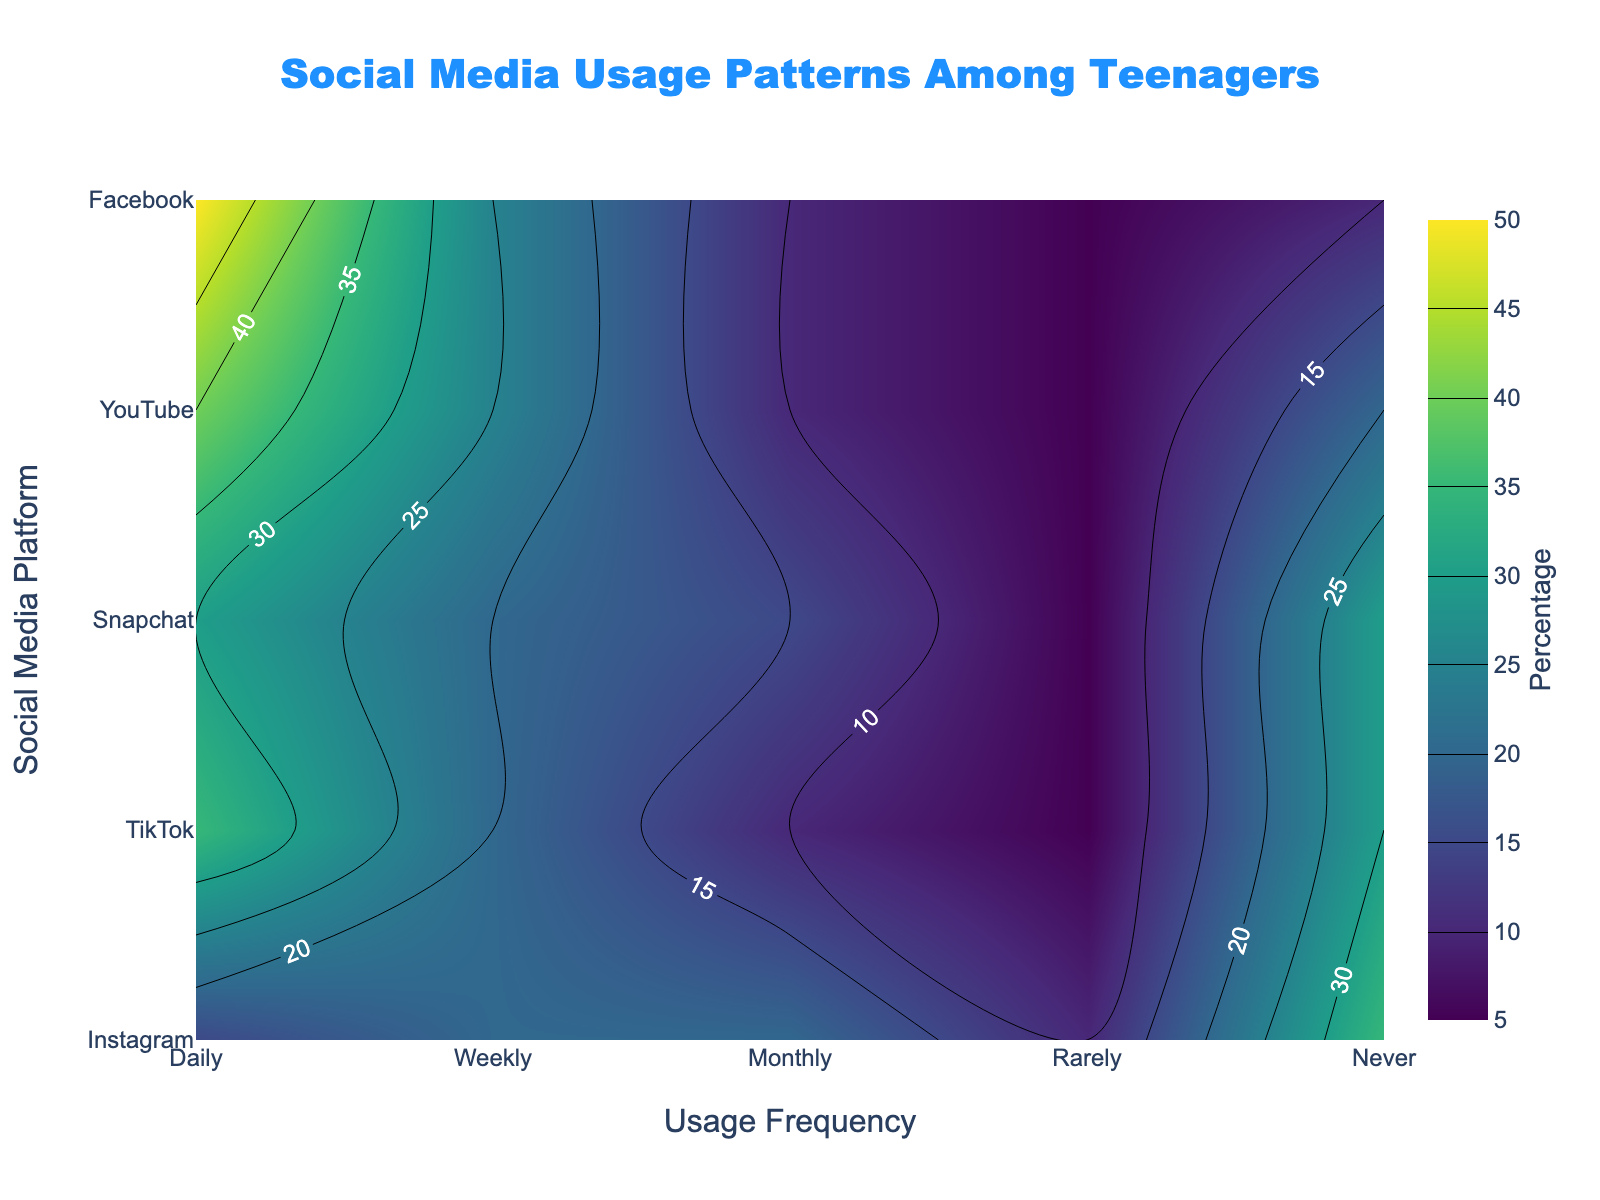What is the title of the plot? The title is prominently displayed at the top center of the plot.
Answer: Social Media Usage Patterns Among Teenagers Which social media platform has the highest percentage for 'Daily' usage? By looking at the contours for 'Daily' on the x-axis, we see the highest value at 'YouTube'.
Answer: YouTube How many social media platforms were analyzed in the plot? The y-axis lists the social media platforms. Counting them gives us the total.
Answer: 5 Which frequency category has the lowest percentage for Instagram? By examining the 'Instagram' row on the y-axis, the lowest contour value appears under the 'Rarely' category.
Answer: Rarely What is the percentage of teenagers who use Facebook 'Monthly'? Locate 'Facebook' on the y-axis and then trace to the 'Monthly' category on the x-axis. The intersection shows the percentage.
Answer: 20% Compare the 'Daily' usage percentages between TikTok and Snapchat. Which one is higher and by how much? Find the values for 'Daily' under TikTok and Snapchat. TikTok is 40% and Snapchat is 30%. Subtracting them gives the difference.
Answer: TikTok; 10% What is the combined percentage of teenagers who use Instagram either 'Daily' or 'Weekly'? Add the percentages for 'Daily' and 'Weekly' usage of Instagram. 35% + 20%.
Answer: 55% For which platform and frequency combination is the percentage closest to 25%? By visually inspecting the contour values, 'TikTok' at 'Weekly' usage category matches this value.
Answer: TikTok; Weekly What is the average 'Daily' usage percentage across all social media platforms in the plot? Find and sum the 'Daily' usage percentages: (35% + 40% + 30% + 50% + 15%) and divide by the number of platforms (5).
Answer: 34% Between Instagram and YouTube, which platform has a higher 'Never' usage percentage and what is the difference? Compare 'Never' usage percentages; Instagram has 30%, and YouTube has 10%. The difference is 30% - 10%.
Answer: Instagram; 20% 